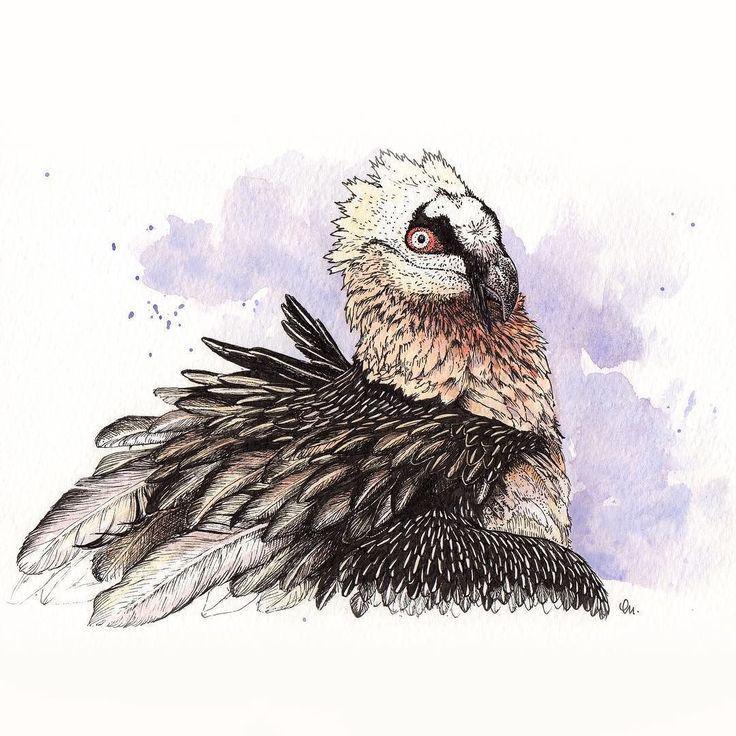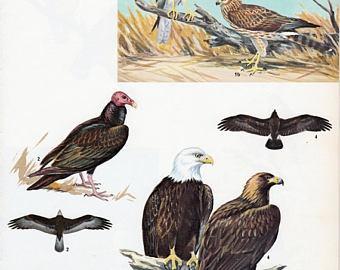The first image is the image on the left, the second image is the image on the right. Assess this claim about the two images: "There are 2 birds.". Correct or not? Answer yes or no. No. 